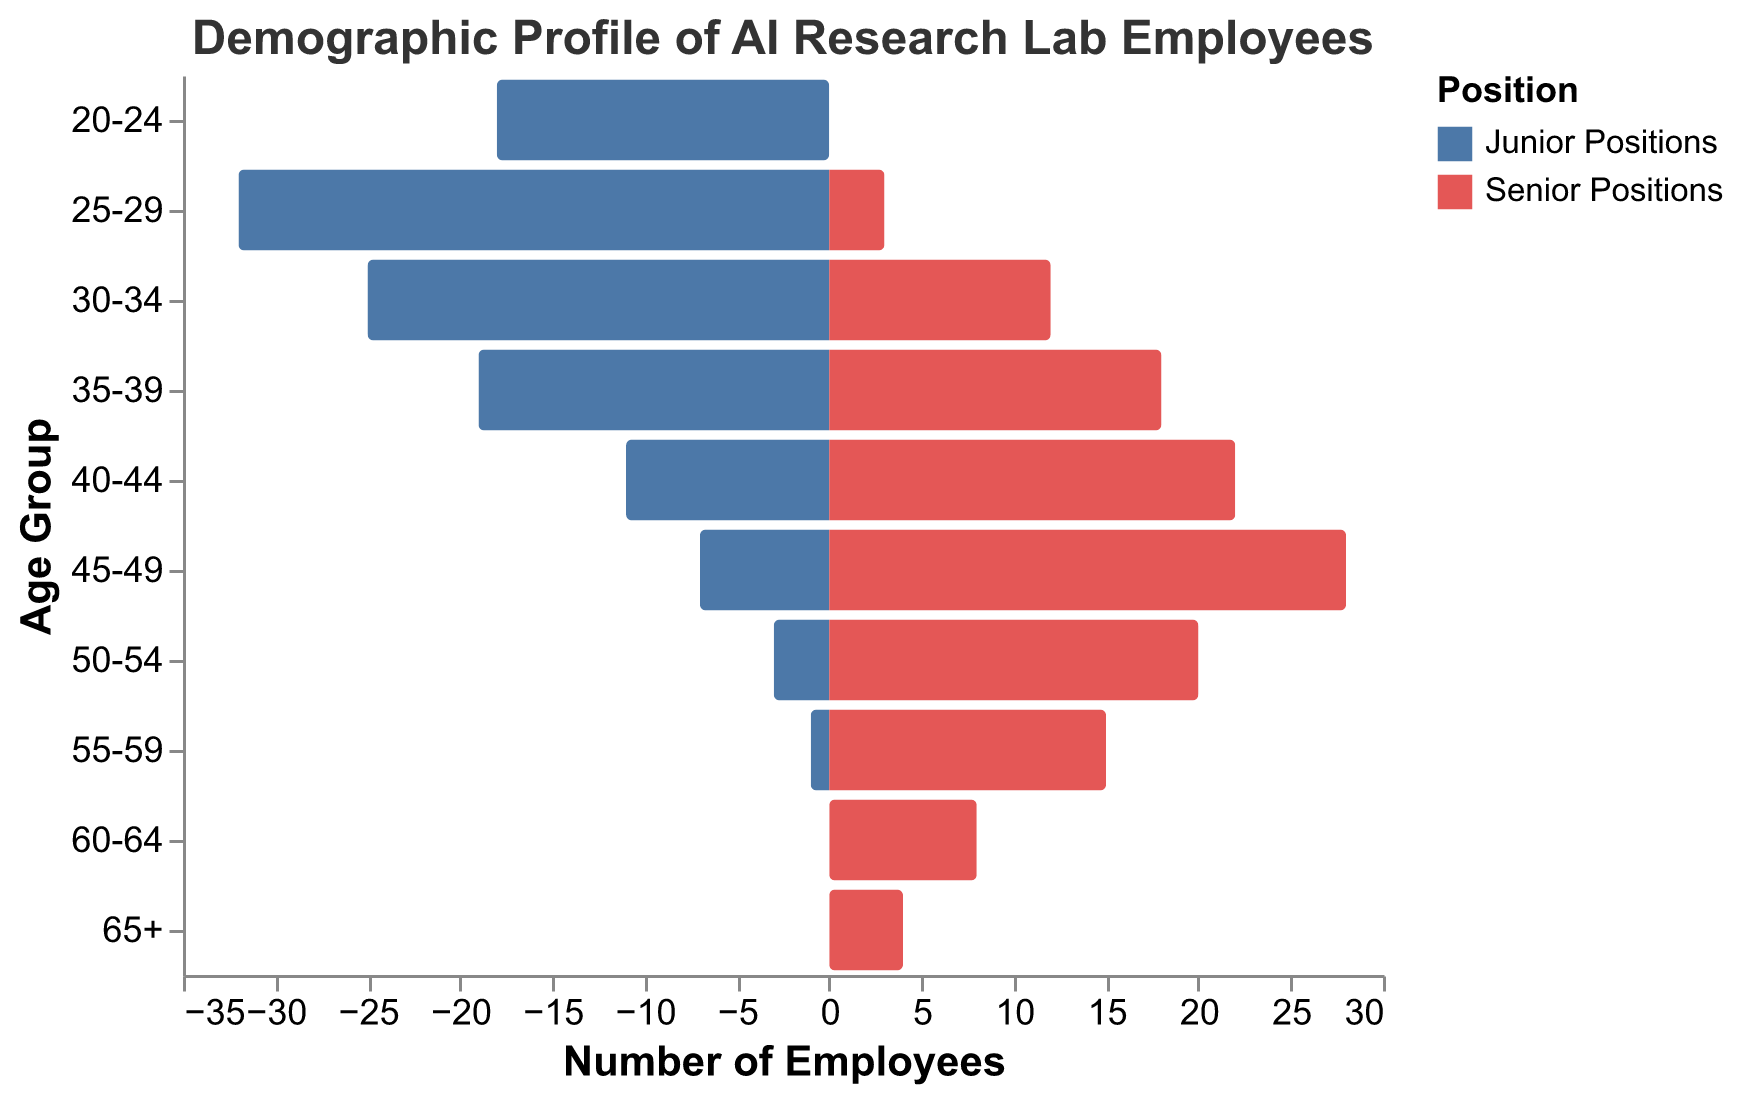What is the title of the figure? The title is located at the top of the figure and generally provides a brief description of the data being visualized.
Answer: Demographic Profile of AI Research Lab Employees How many age groups are represented in the figure? The age groups correspond to distinct categories on the y-axis of the figure. Counting these categories gives the number of age groups.
Answer: 10 Which age group has the highest number of junior positions? Look at the bars corresponding to "Junior Positions" and identify the longest bar. The age group at this bar’s level is the one with the highest number of junior positions.
Answer: 25-29 How many total employees are there in the age group 35-39? Add the counts of junior and senior positions for the age group 35-39: 19 junior + 18 senior.
Answer: 37 What is the difference in the number of senior positions between the 45-49 and 50-54 age groups? Subtract the count of senior positions in 50-54 (20) from the count in 45-49 (28).
Answer: 8 In which age group do senior positions first outnumber junior positions? Compare the counts of junior and senior positions for each age group, starting from the youngest. The age group where the count of senior positions exceeds junior positions for the first time is the answer.
Answer: 35-39 What is the total number of employees in senior positions across all age groups? Add up the senior positions for all age groups: 0 + 3 + 12 + 18 + 22 + 28 + 20 + 15 + 8 + 4.
Answer: 130 Which age group has an equal number of junior and senior positions? Find the age group where the counts of junior and senior positions are the same.
Answer: 35-39 What is the total number of junior employees under the age of 30? Sum the counts of junior positions for age groups 20-24 (18) and 25-29 (32).
Answer: 50 Is there any age group with no junior positions? If yes, which one? Scan through the age groups and find any group where the count of junior positions is zero.
Answer: Yes, 60-64 and 65+ 